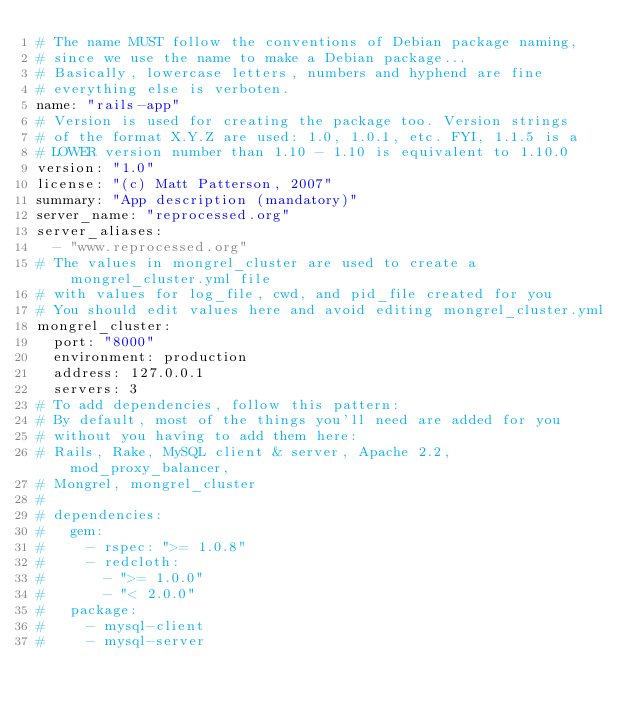Convert code to text. <code><loc_0><loc_0><loc_500><loc_500><_YAML_># The name MUST follow the conventions of Debian package naming,
# since we use the name to make a Debian package...
# Basically, lowercase letters, numbers and hyphend are fine
# everything else is verboten. 
name: "rails-app"
# Version is used for creating the package too. Version strings 
# of the format X.Y.Z are used: 1.0, 1.0.1, etc. FYI, 1.1.5 is a 
# LOWER version number than 1.10 - 1.10 is equivalent to 1.10.0
version: "1.0"
license: "(c) Matt Patterson, 2007"
summary: "App description (mandatory)"
server_name: "reprocessed.org"
server_aliases: 
  - "www.reprocessed.org"
# The values in mongrel_cluster are used to create a mongrel_cluster.yml file
# with values for log_file, cwd, and pid_file created for you
# You should edit values here and avoid editing mongrel_cluster.yml
mongrel_cluster:
  port: "8000"
  environment: production
  address: 127.0.0.1
  servers: 3
# To add dependencies, follow this pattern:
# By default, most of the things you'll need are added for you
# without you having to add them here:
# Rails, Rake, MySQL client & server, Apache 2.2, mod_proxy_balancer,
# Mongrel, mongrel_cluster
#
# dependencies:
#   gem:
#     - rspec: ">= 1.0.8"
#     - redcloth: 
#       - ">= 1.0.0"
#       - "< 2.0.0"
#   package:
#     - mysql-client
#     - mysql-server</code> 